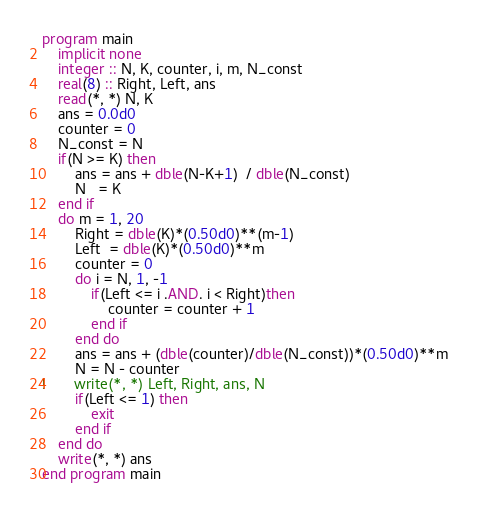<code> <loc_0><loc_0><loc_500><loc_500><_FORTRAN_>program main
	implicit none
	integer :: N, K, counter, i, m, N_const
	real(8) :: Right, Left, ans
	read(*, *) N, K
	ans = 0.0d0
	counter = 0
	N_const = N
	if(N >= K) then
		ans = ans + dble(N-K+1)  / dble(N_const)
		N   = K
	end if
	do m = 1, 20
		Right = dble(K)*(0.50d0)**(m-1)
		Left  = dble(K)*(0.50d0)**m
		counter = 0
		do i = N, 1, -1
			if(Left <= i .AND. i < Right)then
				counter = counter + 1
			end if
		end do
		ans = ans + (dble(counter)/dble(N_const))*(0.50d0)**m
		N = N - counter
!		write(*, *) Left, Right, ans, N
		if(Left <= 1) then
			exit
		end if
	end do
	write(*, *) ans
end program main</code> 